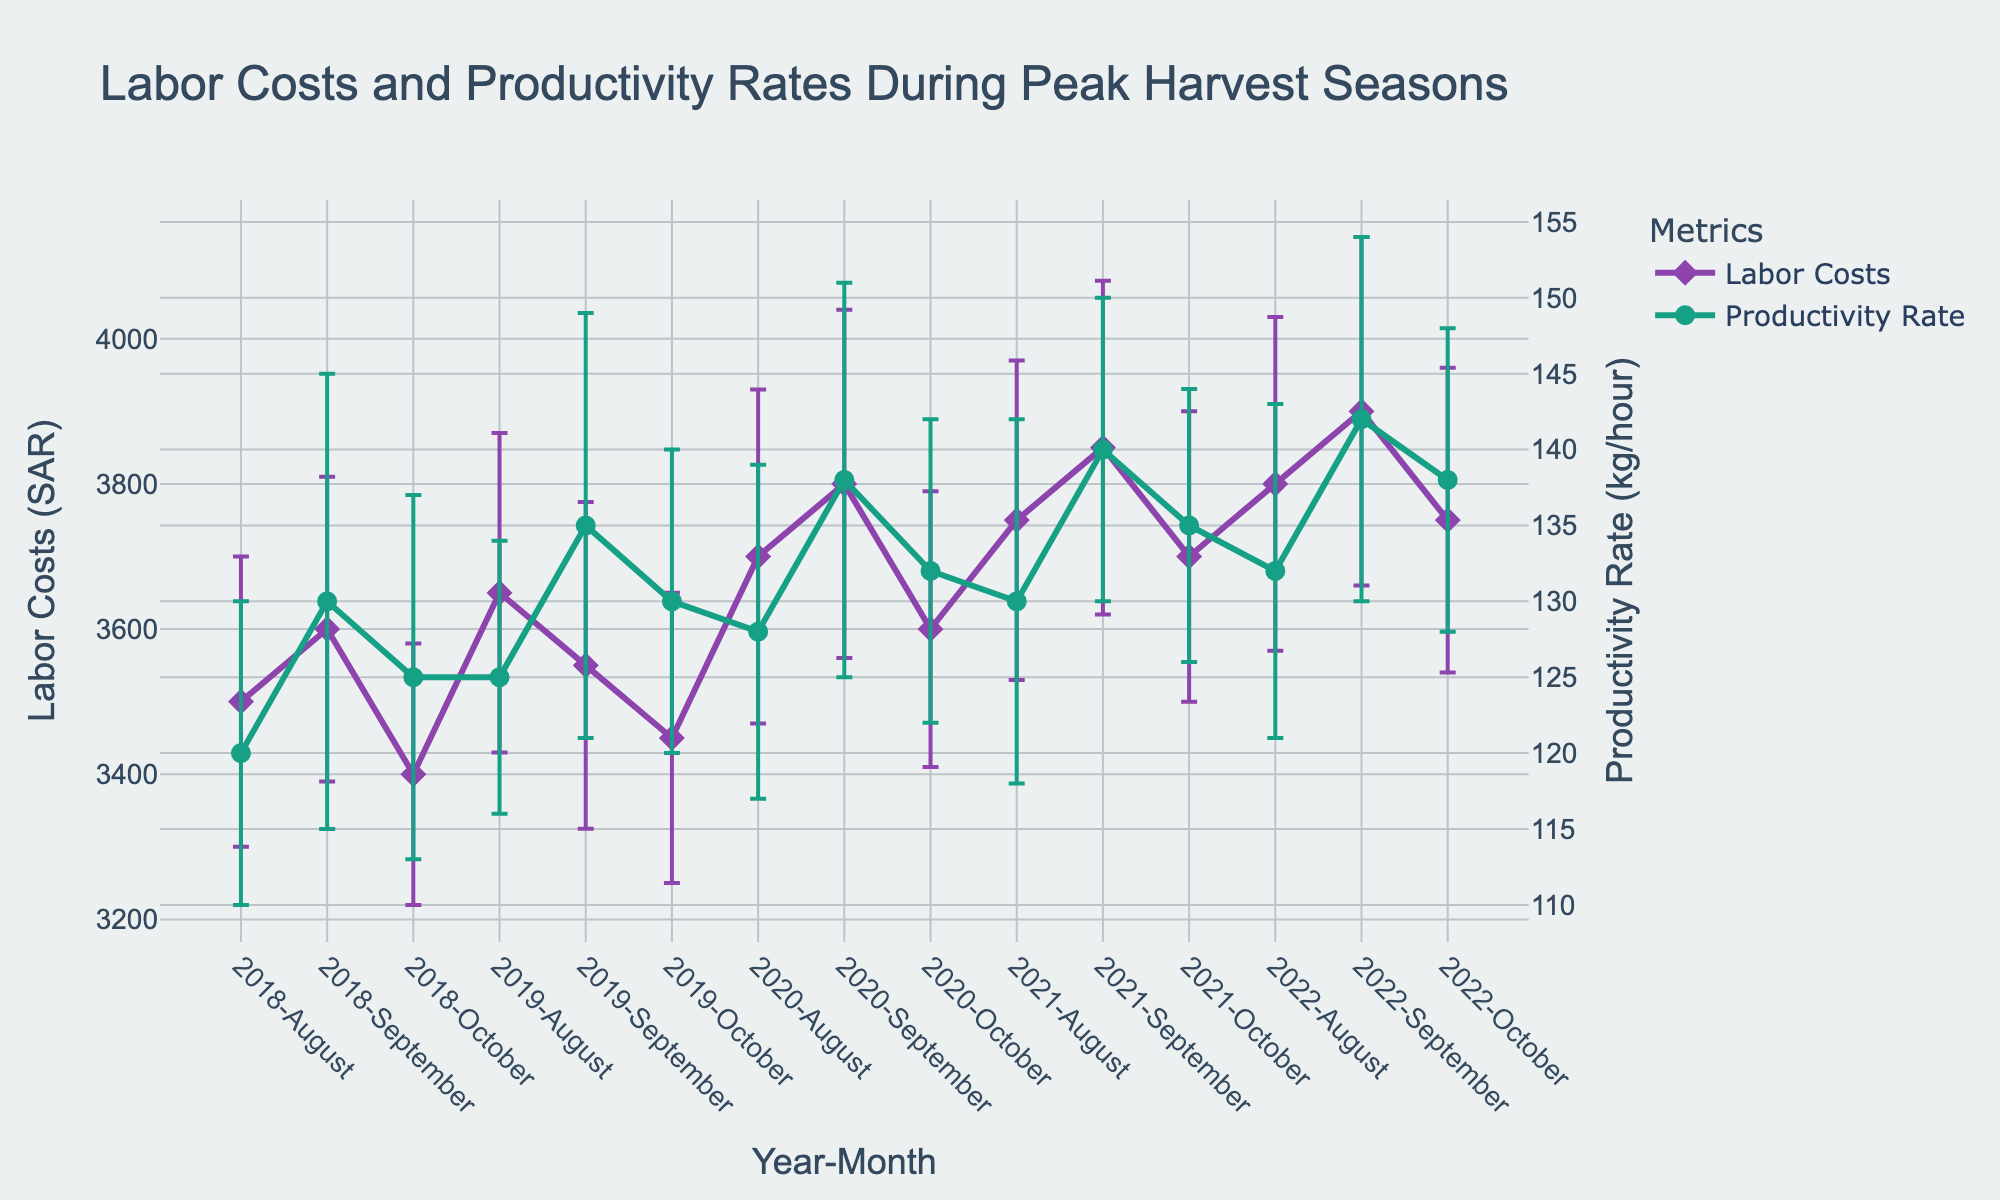How many years of data does the figure represent? The title and x-axis labels show data for different months and years. By counting distinct years in the x-axis labels, we observe data spanning from 2018 to 2022.
Answer: 5 Which month in 2021 had the highest productivity rate? Observe the green line (Productivity Rate) for the year 2021, and note the values for August, September, and October. The highest productivity rate in 2021 occurs in September.
Answer: September What was the trend of labor costs in September from 2018 to 2022? Follow the purple line (Labor Costs) specifically for September from 2018 to 2022. The costs increased each year from 3600 in 2018, 3550 in 2019, 3800 in 2020, 3850 in 2021, to 3900 in 2022.
Answer: Increasing What is the error range for Productivity Rate in October 2020? Locate the green data point for Productivity Rate in October 2020. The error bar tells us the error range, which is ±10. Therefore, the range is 122 to 142 (132 ± 10).
Answer: 122 to 142 Compare the productivity rate and labor costs for August 2020 to August 2021. Which year had higher values? For August 2020, the Productivity Rate is 128 and Labor Costs are 3700. For August 2021, the Productivity Rate is 130 and Labor Costs are 3750. Both Productivity Rate and Labor Costs are higher in 2021.
Answer: 2021 What is the maximum error in labor costs observed and in which year and month does it occur? Identify the maximum value from the error bars on the purple line (Labor Costs). The highest error is 230, which occurs in August 2020.
Answer: August 2020 When were labor costs at their lowest and productivity rates at their highest simultaneously? Look for the lowest point on the purple line (Labor Costs) and the highest point on the green line (Productivity Rate) occurring at the same time. This does not happen simultaneously in the given data.
Answer: Never How do the productivity rates in October compare over the five years? Collect the values for Productivity Rate in October from each year: 125 (2018), 130 (2019), 132 (2020), 135 (2021), and 138 (2022). The productivity rate gradually increases each year.
Answer: Increasing What is the difference in labor costs between August and October 2019? Obtain labor cost values for August 2019 (3650) and October 2019 (3450). The difference is 3650 - 3450 = 200.
Answer: 200 SAR How consistent were Productivity Rates in September across the five years based on the error bars? Review the green line and error bars for Productivity Rate in September over the five years. The error bars vary slightly, indicating moderate consistency, though with some fluctuation.
Answer: Moderately consistent 